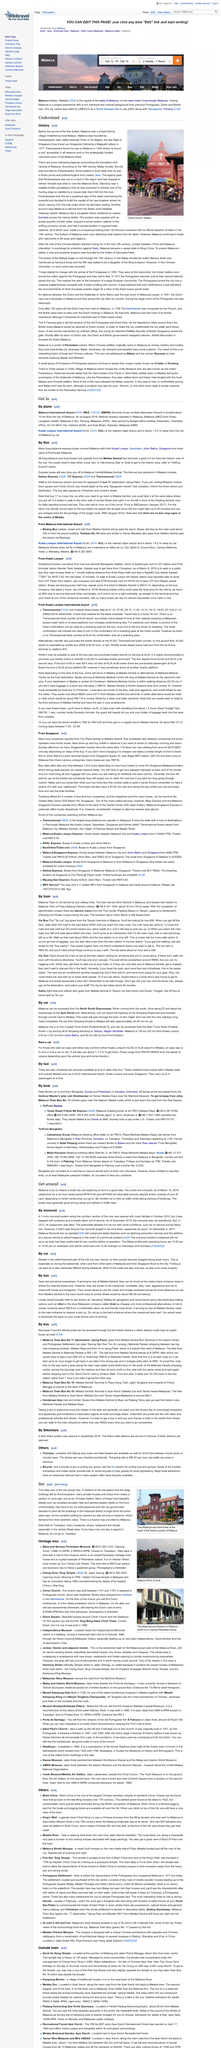List a handful of essential elements in this visual. Bukit China translates to Chinese Hill in English. The fishing village of Malacca was inhabited by local Malays prior to the arrival of the first Sultan, where it became a significant historical site with a rich cultural heritage. The Baba and Nyonya Peranakan Museum charges RM15 per person for entry, and visitors must join a guided group tour. The Geok Hu Keng Temple is located at the junction of Klebang and Jalan Pokok Mangga. The airport is approximately 10 kilometers from the city, which is a significant distance. 